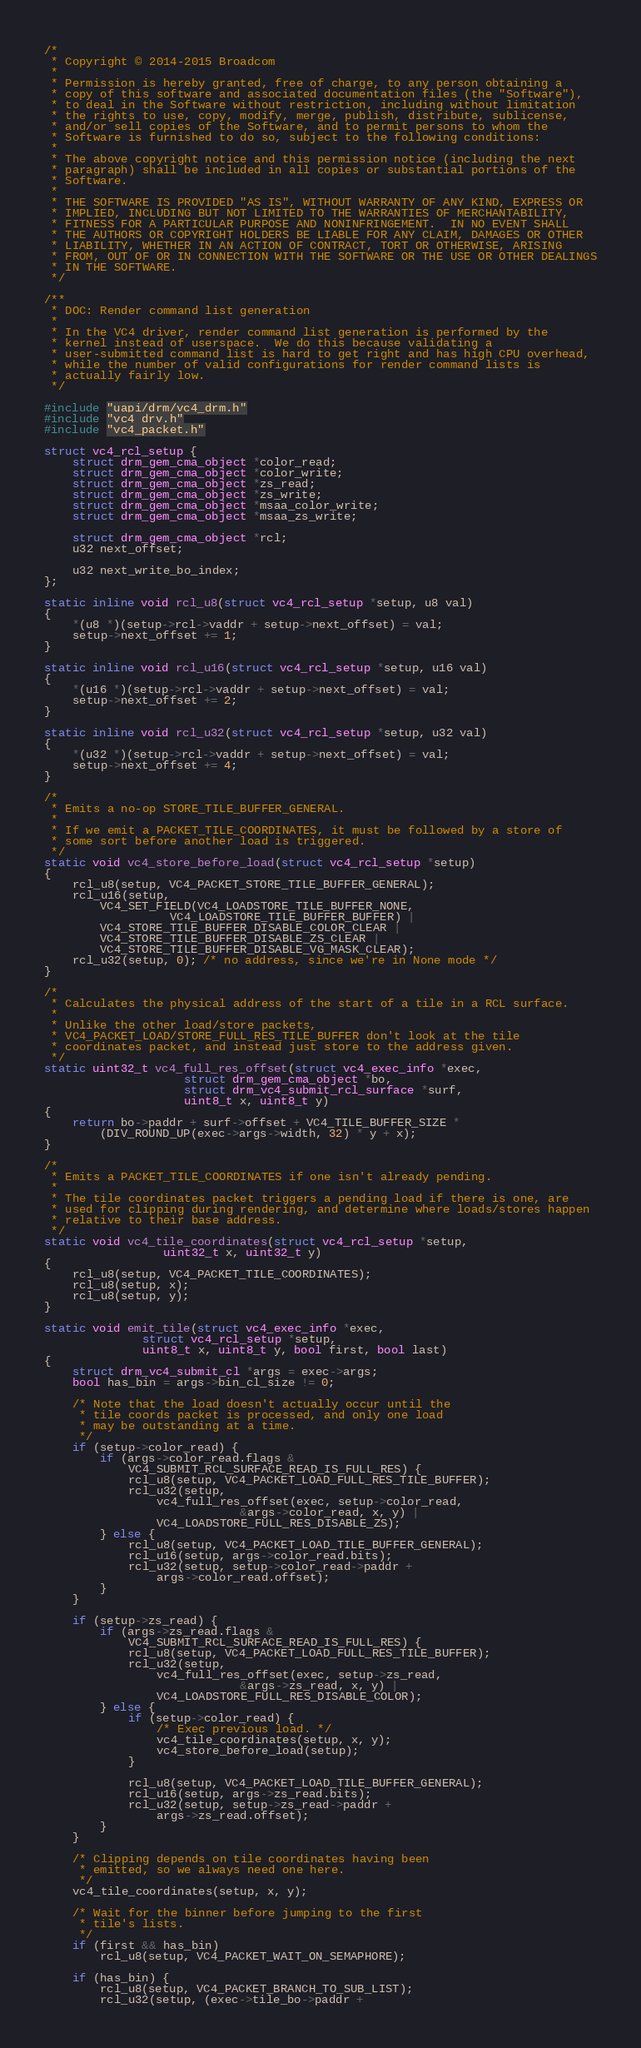Convert code to text. <code><loc_0><loc_0><loc_500><loc_500><_C_>/*
 * Copyright © 2014-2015 Broadcom
 *
 * Permission is hereby granted, free of charge, to any person obtaining a
 * copy of this software and associated documentation files (the "Software"),
 * to deal in the Software without restriction, including without limitation
 * the rights to use, copy, modify, merge, publish, distribute, sublicense,
 * and/or sell copies of the Software, and to permit persons to whom the
 * Software is furnished to do so, subject to the following conditions:
 *
 * The above copyright notice and this permission notice (including the next
 * paragraph) shall be included in all copies or substantial portions of the
 * Software.
 *
 * THE SOFTWARE IS PROVIDED "AS IS", WITHOUT WARRANTY OF ANY KIND, EXPRESS OR
 * IMPLIED, INCLUDING BUT NOT LIMITED TO THE WARRANTIES OF MERCHANTABILITY,
 * FITNESS FOR A PARTICULAR PURPOSE AND NONINFRINGEMENT.  IN NO EVENT SHALL
 * THE AUTHORS OR COPYRIGHT HOLDERS BE LIABLE FOR ANY CLAIM, DAMAGES OR OTHER
 * LIABILITY, WHETHER IN AN ACTION OF CONTRACT, TORT OR OTHERWISE, ARISING
 * FROM, OUT OF OR IN CONNECTION WITH THE SOFTWARE OR THE USE OR OTHER DEALINGS
 * IN THE SOFTWARE.
 */

/**
 * DOC: Render command list generation
 *
 * In the VC4 driver, render command list generation is performed by the
 * kernel instead of userspace.  We do this because validating a
 * user-submitted command list is hard to get right and has high CPU overhead,
 * while the number of valid configurations for render command lists is
 * actually fairly low.
 */

#include "uapi/drm/vc4_drm.h"
#include "vc4_drv.h"
#include "vc4_packet.h"

struct vc4_rcl_setup {
	struct drm_gem_cma_object *color_read;
	struct drm_gem_cma_object *color_write;
	struct drm_gem_cma_object *zs_read;
	struct drm_gem_cma_object *zs_write;
	struct drm_gem_cma_object *msaa_color_write;
	struct drm_gem_cma_object *msaa_zs_write;

	struct drm_gem_cma_object *rcl;
	u32 next_offset;

	u32 next_write_bo_index;
};

static inline void rcl_u8(struct vc4_rcl_setup *setup, u8 val)
{
	*(u8 *)(setup->rcl->vaddr + setup->next_offset) = val;
	setup->next_offset += 1;
}

static inline void rcl_u16(struct vc4_rcl_setup *setup, u16 val)
{
	*(u16 *)(setup->rcl->vaddr + setup->next_offset) = val;
	setup->next_offset += 2;
}

static inline void rcl_u32(struct vc4_rcl_setup *setup, u32 val)
{
	*(u32 *)(setup->rcl->vaddr + setup->next_offset) = val;
	setup->next_offset += 4;
}

/*
 * Emits a no-op STORE_TILE_BUFFER_GENERAL.
 *
 * If we emit a PACKET_TILE_COORDINATES, it must be followed by a store of
 * some sort before another load is triggered.
 */
static void vc4_store_before_load(struct vc4_rcl_setup *setup)
{
	rcl_u8(setup, VC4_PACKET_STORE_TILE_BUFFER_GENERAL);
	rcl_u16(setup,
		VC4_SET_FIELD(VC4_LOADSTORE_TILE_BUFFER_NONE,
			      VC4_LOADSTORE_TILE_BUFFER_BUFFER) |
		VC4_STORE_TILE_BUFFER_DISABLE_COLOR_CLEAR |
		VC4_STORE_TILE_BUFFER_DISABLE_ZS_CLEAR |
		VC4_STORE_TILE_BUFFER_DISABLE_VG_MASK_CLEAR);
	rcl_u32(setup, 0); /* no address, since we're in None mode */
}

/*
 * Calculates the physical address of the start of a tile in a RCL surface.
 *
 * Unlike the other load/store packets,
 * VC4_PACKET_LOAD/STORE_FULL_RES_TILE_BUFFER don't look at the tile
 * coordinates packet, and instead just store to the address given.
 */
static uint32_t vc4_full_res_offset(struct vc4_exec_info *exec,
				    struct drm_gem_cma_object *bo,
				    struct drm_vc4_submit_rcl_surface *surf,
				    uint8_t x, uint8_t y)
{
	return bo->paddr + surf->offset + VC4_TILE_BUFFER_SIZE *
		(DIV_ROUND_UP(exec->args->width, 32) * y + x);
}

/*
 * Emits a PACKET_TILE_COORDINATES if one isn't already pending.
 *
 * The tile coordinates packet triggers a pending load if there is one, are
 * used for clipping during rendering, and determine where loads/stores happen
 * relative to their base address.
 */
static void vc4_tile_coordinates(struct vc4_rcl_setup *setup,
				 uint32_t x, uint32_t y)
{
	rcl_u8(setup, VC4_PACKET_TILE_COORDINATES);
	rcl_u8(setup, x);
	rcl_u8(setup, y);
}

static void emit_tile(struct vc4_exec_info *exec,
		      struct vc4_rcl_setup *setup,
		      uint8_t x, uint8_t y, bool first, bool last)
{
	struct drm_vc4_submit_cl *args = exec->args;
	bool has_bin = args->bin_cl_size != 0;

	/* Note that the load doesn't actually occur until the
	 * tile coords packet is processed, and only one load
	 * may be outstanding at a time.
	 */
	if (setup->color_read) {
		if (args->color_read.flags &
		    VC4_SUBMIT_RCL_SURFACE_READ_IS_FULL_RES) {
			rcl_u8(setup, VC4_PACKET_LOAD_FULL_RES_TILE_BUFFER);
			rcl_u32(setup,
				vc4_full_res_offset(exec, setup->color_read,
						    &args->color_read, x, y) |
				VC4_LOADSTORE_FULL_RES_DISABLE_ZS);
		} else {
			rcl_u8(setup, VC4_PACKET_LOAD_TILE_BUFFER_GENERAL);
			rcl_u16(setup, args->color_read.bits);
			rcl_u32(setup, setup->color_read->paddr +
				args->color_read.offset);
		}
	}

	if (setup->zs_read) {
		if (args->zs_read.flags &
		    VC4_SUBMIT_RCL_SURFACE_READ_IS_FULL_RES) {
			rcl_u8(setup, VC4_PACKET_LOAD_FULL_RES_TILE_BUFFER);
			rcl_u32(setup,
				vc4_full_res_offset(exec, setup->zs_read,
						    &args->zs_read, x, y) |
				VC4_LOADSTORE_FULL_RES_DISABLE_COLOR);
		} else {
			if (setup->color_read) {
				/* Exec previous load. */
				vc4_tile_coordinates(setup, x, y);
				vc4_store_before_load(setup);
			}

			rcl_u8(setup, VC4_PACKET_LOAD_TILE_BUFFER_GENERAL);
			rcl_u16(setup, args->zs_read.bits);
			rcl_u32(setup, setup->zs_read->paddr +
				args->zs_read.offset);
		}
	}

	/* Clipping depends on tile coordinates having been
	 * emitted, so we always need one here.
	 */
	vc4_tile_coordinates(setup, x, y);

	/* Wait for the binner before jumping to the first
	 * tile's lists.
	 */
	if (first && has_bin)
		rcl_u8(setup, VC4_PACKET_WAIT_ON_SEMAPHORE);

	if (has_bin) {
		rcl_u8(setup, VC4_PACKET_BRANCH_TO_SUB_LIST);
		rcl_u32(setup, (exec->tile_bo->paddr +</code> 